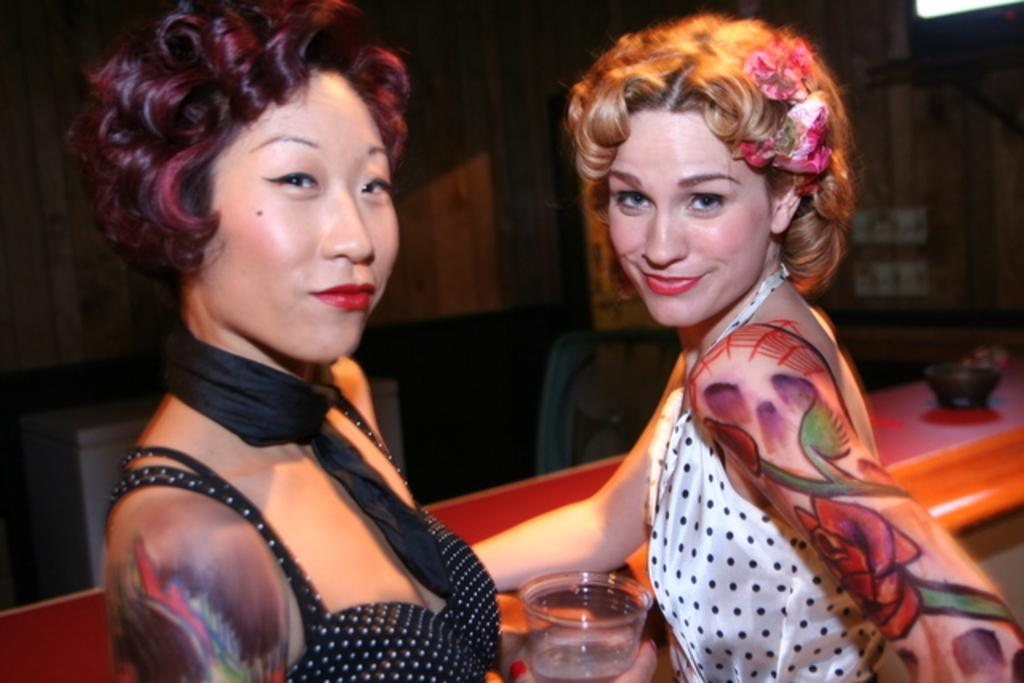How many people are in the image? There are two women in the image. What is the facial expression of the women? Both women are smiling. Can you describe what one of the women is holding? One of the women is holding a glass in her hand. What type of celery is the woman holding in the image? There is no celery present in the image; one of the women is holding a glass. How many books can be seen in the image? There are no books visible in the image. 